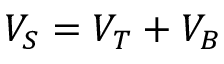Convert formula to latex. <formula><loc_0><loc_0><loc_500><loc_500>V _ { S } = V _ { T } + V _ { B }</formula> 